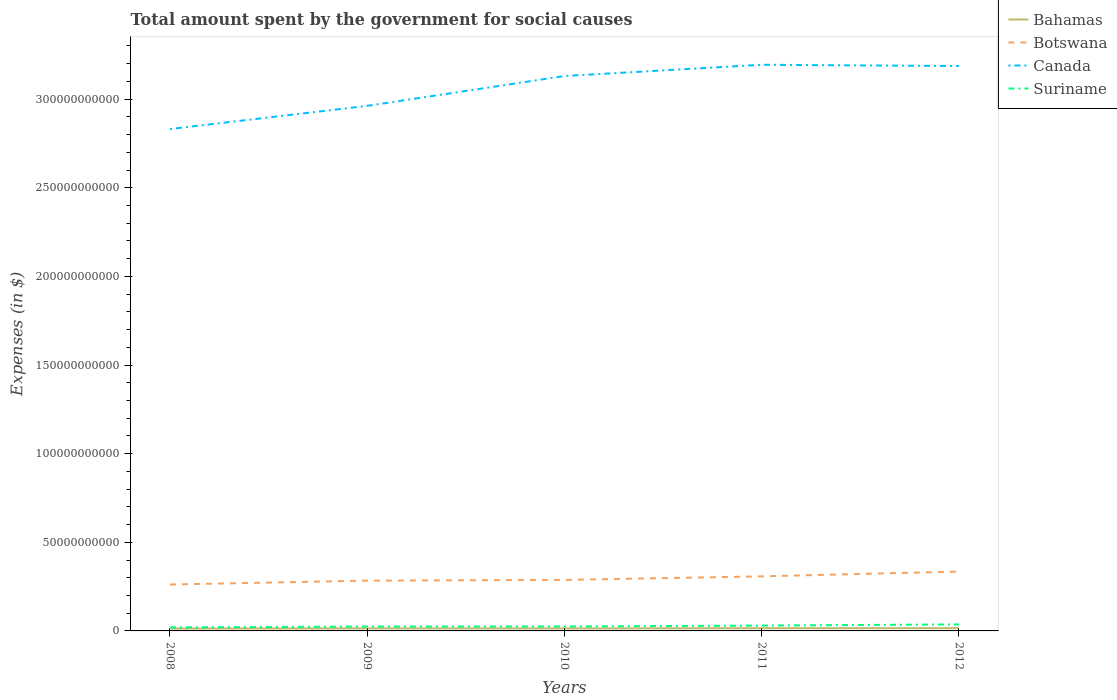Does the line corresponding to Botswana intersect with the line corresponding to Suriname?
Your answer should be compact. No. Is the number of lines equal to the number of legend labels?
Offer a very short reply. Yes. Across all years, what is the maximum amount spent for social causes by the government in Bahamas?
Make the answer very short. 1.34e+09. In which year was the amount spent for social causes by the government in Botswana maximum?
Offer a very short reply. 2008. What is the total amount spent for social causes by the government in Canada in the graph?
Give a very brief answer. -5.62e+09. What is the difference between the highest and the second highest amount spent for social causes by the government in Canada?
Provide a succinct answer. 3.63e+1. Is the amount spent for social causes by the government in Bahamas strictly greater than the amount spent for social causes by the government in Suriname over the years?
Provide a short and direct response. Yes. Are the values on the major ticks of Y-axis written in scientific E-notation?
Provide a short and direct response. No. Does the graph contain grids?
Give a very brief answer. No. How many legend labels are there?
Offer a terse response. 4. How are the legend labels stacked?
Offer a very short reply. Vertical. What is the title of the graph?
Offer a very short reply. Total amount spent by the government for social causes. Does "Trinidad and Tobago" appear as one of the legend labels in the graph?
Give a very brief answer. No. What is the label or title of the X-axis?
Give a very brief answer. Years. What is the label or title of the Y-axis?
Your answer should be very brief. Expenses (in $). What is the Expenses (in $) of Bahamas in 2008?
Make the answer very short. 1.34e+09. What is the Expenses (in $) in Botswana in 2008?
Offer a terse response. 2.62e+1. What is the Expenses (in $) in Canada in 2008?
Provide a short and direct response. 2.83e+11. What is the Expenses (in $) in Suriname in 2008?
Make the answer very short. 1.99e+09. What is the Expenses (in $) of Bahamas in 2009?
Keep it short and to the point. 1.42e+09. What is the Expenses (in $) of Botswana in 2009?
Provide a succinct answer. 2.84e+1. What is the Expenses (in $) in Canada in 2009?
Your answer should be very brief. 2.96e+11. What is the Expenses (in $) in Suriname in 2009?
Offer a very short reply. 2.47e+09. What is the Expenses (in $) in Bahamas in 2010?
Offer a terse response. 1.40e+09. What is the Expenses (in $) in Botswana in 2010?
Give a very brief answer. 2.88e+1. What is the Expenses (in $) of Canada in 2010?
Keep it short and to the point. 3.13e+11. What is the Expenses (in $) of Suriname in 2010?
Ensure brevity in your answer.  2.50e+09. What is the Expenses (in $) of Bahamas in 2011?
Your response must be concise. 1.53e+09. What is the Expenses (in $) in Botswana in 2011?
Offer a terse response. 3.08e+1. What is the Expenses (in $) of Canada in 2011?
Provide a short and direct response. 3.19e+11. What is the Expenses (in $) of Suriname in 2011?
Offer a very short reply. 3.02e+09. What is the Expenses (in $) in Bahamas in 2012?
Offer a very short reply. 1.55e+09. What is the Expenses (in $) of Botswana in 2012?
Provide a succinct answer. 3.35e+1. What is the Expenses (in $) of Canada in 2012?
Your response must be concise. 3.19e+11. What is the Expenses (in $) of Suriname in 2012?
Offer a very short reply. 3.68e+09. Across all years, what is the maximum Expenses (in $) of Bahamas?
Ensure brevity in your answer.  1.55e+09. Across all years, what is the maximum Expenses (in $) of Botswana?
Your answer should be compact. 3.35e+1. Across all years, what is the maximum Expenses (in $) of Canada?
Your response must be concise. 3.19e+11. Across all years, what is the maximum Expenses (in $) of Suriname?
Offer a terse response. 3.68e+09. Across all years, what is the minimum Expenses (in $) in Bahamas?
Offer a terse response. 1.34e+09. Across all years, what is the minimum Expenses (in $) of Botswana?
Provide a short and direct response. 2.62e+1. Across all years, what is the minimum Expenses (in $) of Canada?
Ensure brevity in your answer.  2.83e+11. Across all years, what is the minimum Expenses (in $) of Suriname?
Your answer should be very brief. 1.99e+09. What is the total Expenses (in $) in Bahamas in the graph?
Offer a terse response. 7.24e+09. What is the total Expenses (in $) in Botswana in the graph?
Your answer should be very brief. 1.48e+11. What is the total Expenses (in $) in Canada in the graph?
Give a very brief answer. 1.53e+12. What is the total Expenses (in $) of Suriname in the graph?
Give a very brief answer. 1.37e+1. What is the difference between the Expenses (in $) of Bahamas in 2008 and that in 2009?
Keep it short and to the point. -7.68e+07. What is the difference between the Expenses (in $) of Botswana in 2008 and that in 2009?
Offer a very short reply. -2.17e+09. What is the difference between the Expenses (in $) in Canada in 2008 and that in 2009?
Provide a succinct answer. -1.31e+1. What is the difference between the Expenses (in $) of Suriname in 2008 and that in 2009?
Keep it short and to the point. -4.80e+08. What is the difference between the Expenses (in $) of Bahamas in 2008 and that in 2010?
Make the answer very short. -5.18e+07. What is the difference between the Expenses (in $) of Botswana in 2008 and that in 2010?
Make the answer very short. -2.58e+09. What is the difference between the Expenses (in $) in Canada in 2008 and that in 2010?
Ensure brevity in your answer.  -2.99e+1. What is the difference between the Expenses (in $) in Suriname in 2008 and that in 2010?
Your answer should be very brief. -5.14e+08. What is the difference between the Expenses (in $) in Bahamas in 2008 and that in 2011?
Your answer should be very brief. -1.82e+08. What is the difference between the Expenses (in $) of Botswana in 2008 and that in 2011?
Make the answer very short. -4.59e+09. What is the difference between the Expenses (in $) of Canada in 2008 and that in 2011?
Provide a short and direct response. -3.63e+1. What is the difference between the Expenses (in $) of Suriname in 2008 and that in 2011?
Give a very brief answer. -1.03e+09. What is the difference between the Expenses (in $) in Bahamas in 2008 and that in 2012?
Offer a terse response. -2.08e+08. What is the difference between the Expenses (in $) in Botswana in 2008 and that in 2012?
Keep it short and to the point. -7.30e+09. What is the difference between the Expenses (in $) of Canada in 2008 and that in 2012?
Keep it short and to the point. -3.55e+1. What is the difference between the Expenses (in $) of Suriname in 2008 and that in 2012?
Offer a very short reply. -1.69e+09. What is the difference between the Expenses (in $) in Bahamas in 2009 and that in 2010?
Your answer should be very brief. 2.50e+07. What is the difference between the Expenses (in $) of Botswana in 2009 and that in 2010?
Ensure brevity in your answer.  -4.12e+08. What is the difference between the Expenses (in $) in Canada in 2009 and that in 2010?
Ensure brevity in your answer.  -1.68e+1. What is the difference between the Expenses (in $) of Suriname in 2009 and that in 2010?
Ensure brevity in your answer.  -3.39e+07. What is the difference between the Expenses (in $) in Bahamas in 2009 and that in 2011?
Your answer should be compact. -1.06e+08. What is the difference between the Expenses (in $) in Botswana in 2009 and that in 2011?
Give a very brief answer. -2.42e+09. What is the difference between the Expenses (in $) in Canada in 2009 and that in 2011?
Give a very brief answer. -2.32e+1. What is the difference between the Expenses (in $) in Suriname in 2009 and that in 2011?
Ensure brevity in your answer.  -5.52e+08. What is the difference between the Expenses (in $) in Bahamas in 2009 and that in 2012?
Offer a terse response. -1.32e+08. What is the difference between the Expenses (in $) in Botswana in 2009 and that in 2012?
Offer a very short reply. -5.13e+09. What is the difference between the Expenses (in $) of Canada in 2009 and that in 2012?
Keep it short and to the point. -2.25e+1. What is the difference between the Expenses (in $) in Suriname in 2009 and that in 2012?
Ensure brevity in your answer.  -1.21e+09. What is the difference between the Expenses (in $) in Bahamas in 2010 and that in 2011?
Provide a short and direct response. -1.31e+08. What is the difference between the Expenses (in $) of Botswana in 2010 and that in 2011?
Give a very brief answer. -2.00e+09. What is the difference between the Expenses (in $) in Canada in 2010 and that in 2011?
Make the answer very short. -6.35e+09. What is the difference between the Expenses (in $) of Suriname in 2010 and that in 2011?
Ensure brevity in your answer.  -5.18e+08. What is the difference between the Expenses (in $) in Bahamas in 2010 and that in 2012?
Ensure brevity in your answer.  -1.57e+08. What is the difference between the Expenses (in $) in Botswana in 2010 and that in 2012?
Your answer should be very brief. -4.72e+09. What is the difference between the Expenses (in $) in Canada in 2010 and that in 2012?
Your answer should be compact. -5.62e+09. What is the difference between the Expenses (in $) in Suriname in 2010 and that in 2012?
Provide a succinct answer. -1.18e+09. What is the difference between the Expenses (in $) of Bahamas in 2011 and that in 2012?
Your answer should be compact. -2.60e+07. What is the difference between the Expenses (in $) in Botswana in 2011 and that in 2012?
Provide a short and direct response. -2.71e+09. What is the difference between the Expenses (in $) of Canada in 2011 and that in 2012?
Make the answer very short. 7.23e+08. What is the difference between the Expenses (in $) in Suriname in 2011 and that in 2012?
Offer a very short reply. -6.62e+08. What is the difference between the Expenses (in $) of Bahamas in 2008 and the Expenses (in $) of Botswana in 2009?
Ensure brevity in your answer.  -2.70e+1. What is the difference between the Expenses (in $) in Bahamas in 2008 and the Expenses (in $) in Canada in 2009?
Offer a terse response. -2.95e+11. What is the difference between the Expenses (in $) of Bahamas in 2008 and the Expenses (in $) of Suriname in 2009?
Your response must be concise. -1.12e+09. What is the difference between the Expenses (in $) of Botswana in 2008 and the Expenses (in $) of Canada in 2009?
Ensure brevity in your answer.  -2.70e+11. What is the difference between the Expenses (in $) of Botswana in 2008 and the Expenses (in $) of Suriname in 2009?
Your answer should be compact. 2.37e+1. What is the difference between the Expenses (in $) of Canada in 2008 and the Expenses (in $) of Suriname in 2009?
Ensure brevity in your answer.  2.81e+11. What is the difference between the Expenses (in $) in Bahamas in 2008 and the Expenses (in $) in Botswana in 2010?
Your answer should be very brief. -2.74e+1. What is the difference between the Expenses (in $) in Bahamas in 2008 and the Expenses (in $) in Canada in 2010?
Make the answer very short. -3.12e+11. What is the difference between the Expenses (in $) in Bahamas in 2008 and the Expenses (in $) in Suriname in 2010?
Keep it short and to the point. -1.16e+09. What is the difference between the Expenses (in $) in Botswana in 2008 and the Expenses (in $) in Canada in 2010?
Make the answer very short. -2.87e+11. What is the difference between the Expenses (in $) of Botswana in 2008 and the Expenses (in $) of Suriname in 2010?
Offer a very short reply. 2.37e+1. What is the difference between the Expenses (in $) in Canada in 2008 and the Expenses (in $) in Suriname in 2010?
Make the answer very short. 2.81e+11. What is the difference between the Expenses (in $) of Bahamas in 2008 and the Expenses (in $) of Botswana in 2011?
Offer a terse response. -2.94e+1. What is the difference between the Expenses (in $) of Bahamas in 2008 and the Expenses (in $) of Canada in 2011?
Keep it short and to the point. -3.18e+11. What is the difference between the Expenses (in $) of Bahamas in 2008 and the Expenses (in $) of Suriname in 2011?
Give a very brief answer. -1.67e+09. What is the difference between the Expenses (in $) in Botswana in 2008 and the Expenses (in $) in Canada in 2011?
Provide a succinct answer. -2.93e+11. What is the difference between the Expenses (in $) in Botswana in 2008 and the Expenses (in $) in Suriname in 2011?
Ensure brevity in your answer.  2.32e+1. What is the difference between the Expenses (in $) in Canada in 2008 and the Expenses (in $) in Suriname in 2011?
Your answer should be compact. 2.80e+11. What is the difference between the Expenses (in $) of Bahamas in 2008 and the Expenses (in $) of Botswana in 2012?
Provide a short and direct response. -3.21e+1. What is the difference between the Expenses (in $) in Bahamas in 2008 and the Expenses (in $) in Canada in 2012?
Your response must be concise. -3.17e+11. What is the difference between the Expenses (in $) in Bahamas in 2008 and the Expenses (in $) in Suriname in 2012?
Make the answer very short. -2.34e+09. What is the difference between the Expenses (in $) in Botswana in 2008 and the Expenses (in $) in Canada in 2012?
Your response must be concise. -2.92e+11. What is the difference between the Expenses (in $) in Botswana in 2008 and the Expenses (in $) in Suriname in 2012?
Give a very brief answer. 2.25e+1. What is the difference between the Expenses (in $) in Canada in 2008 and the Expenses (in $) in Suriname in 2012?
Give a very brief answer. 2.79e+11. What is the difference between the Expenses (in $) of Bahamas in 2009 and the Expenses (in $) of Botswana in 2010?
Offer a terse response. -2.74e+1. What is the difference between the Expenses (in $) in Bahamas in 2009 and the Expenses (in $) in Canada in 2010?
Your answer should be compact. -3.12e+11. What is the difference between the Expenses (in $) in Bahamas in 2009 and the Expenses (in $) in Suriname in 2010?
Keep it short and to the point. -1.08e+09. What is the difference between the Expenses (in $) in Botswana in 2009 and the Expenses (in $) in Canada in 2010?
Keep it short and to the point. -2.85e+11. What is the difference between the Expenses (in $) in Botswana in 2009 and the Expenses (in $) in Suriname in 2010?
Ensure brevity in your answer.  2.59e+1. What is the difference between the Expenses (in $) in Canada in 2009 and the Expenses (in $) in Suriname in 2010?
Your response must be concise. 2.94e+11. What is the difference between the Expenses (in $) of Bahamas in 2009 and the Expenses (in $) of Botswana in 2011?
Provide a succinct answer. -2.94e+1. What is the difference between the Expenses (in $) of Bahamas in 2009 and the Expenses (in $) of Canada in 2011?
Your answer should be very brief. -3.18e+11. What is the difference between the Expenses (in $) of Bahamas in 2009 and the Expenses (in $) of Suriname in 2011?
Offer a terse response. -1.60e+09. What is the difference between the Expenses (in $) in Botswana in 2009 and the Expenses (in $) in Canada in 2011?
Provide a succinct answer. -2.91e+11. What is the difference between the Expenses (in $) in Botswana in 2009 and the Expenses (in $) in Suriname in 2011?
Offer a terse response. 2.53e+1. What is the difference between the Expenses (in $) in Canada in 2009 and the Expenses (in $) in Suriname in 2011?
Your response must be concise. 2.93e+11. What is the difference between the Expenses (in $) in Bahamas in 2009 and the Expenses (in $) in Botswana in 2012?
Provide a succinct answer. -3.21e+1. What is the difference between the Expenses (in $) of Bahamas in 2009 and the Expenses (in $) of Canada in 2012?
Your response must be concise. -3.17e+11. What is the difference between the Expenses (in $) of Bahamas in 2009 and the Expenses (in $) of Suriname in 2012?
Your answer should be very brief. -2.26e+09. What is the difference between the Expenses (in $) in Botswana in 2009 and the Expenses (in $) in Canada in 2012?
Keep it short and to the point. -2.90e+11. What is the difference between the Expenses (in $) in Botswana in 2009 and the Expenses (in $) in Suriname in 2012?
Offer a very short reply. 2.47e+1. What is the difference between the Expenses (in $) of Canada in 2009 and the Expenses (in $) of Suriname in 2012?
Provide a short and direct response. 2.93e+11. What is the difference between the Expenses (in $) of Bahamas in 2010 and the Expenses (in $) of Botswana in 2011?
Offer a very short reply. -2.94e+1. What is the difference between the Expenses (in $) of Bahamas in 2010 and the Expenses (in $) of Canada in 2011?
Offer a very short reply. -3.18e+11. What is the difference between the Expenses (in $) of Bahamas in 2010 and the Expenses (in $) of Suriname in 2011?
Keep it short and to the point. -1.62e+09. What is the difference between the Expenses (in $) in Botswana in 2010 and the Expenses (in $) in Canada in 2011?
Provide a short and direct response. -2.91e+11. What is the difference between the Expenses (in $) of Botswana in 2010 and the Expenses (in $) of Suriname in 2011?
Make the answer very short. 2.58e+1. What is the difference between the Expenses (in $) in Canada in 2010 and the Expenses (in $) in Suriname in 2011?
Offer a terse response. 3.10e+11. What is the difference between the Expenses (in $) of Bahamas in 2010 and the Expenses (in $) of Botswana in 2012?
Your answer should be very brief. -3.21e+1. What is the difference between the Expenses (in $) in Bahamas in 2010 and the Expenses (in $) in Canada in 2012?
Offer a terse response. -3.17e+11. What is the difference between the Expenses (in $) of Bahamas in 2010 and the Expenses (in $) of Suriname in 2012?
Your answer should be very brief. -2.28e+09. What is the difference between the Expenses (in $) of Botswana in 2010 and the Expenses (in $) of Canada in 2012?
Provide a short and direct response. -2.90e+11. What is the difference between the Expenses (in $) in Botswana in 2010 and the Expenses (in $) in Suriname in 2012?
Provide a short and direct response. 2.51e+1. What is the difference between the Expenses (in $) of Canada in 2010 and the Expenses (in $) of Suriname in 2012?
Offer a terse response. 3.09e+11. What is the difference between the Expenses (in $) in Bahamas in 2011 and the Expenses (in $) in Botswana in 2012?
Offer a terse response. -3.20e+1. What is the difference between the Expenses (in $) of Bahamas in 2011 and the Expenses (in $) of Canada in 2012?
Make the answer very short. -3.17e+11. What is the difference between the Expenses (in $) in Bahamas in 2011 and the Expenses (in $) in Suriname in 2012?
Your answer should be very brief. -2.15e+09. What is the difference between the Expenses (in $) of Botswana in 2011 and the Expenses (in $) of Canada in 2012?
Make the answer very short. -2.88e+11. What is the difference between the Expenses (in $) in Botswana in 2011 and the Expenses (in $) in Suriname in 2012?
Offer a terse response. 2.71e+1. What is the difference between the Expenses (in $) of Canada in 2011 and the Expenses (in $) of Suriname in 2012?
Offer a terse response. 3.16e+11. What is the average Expenses (in $) in Bahamas per year?
Provide a short and direct response. 1.45e+09. What is the average Expenses (in $) of Botswana per year?
Your answer should be compact. 2.95e+1. What is the average Expenses (in $) in Canada per year?
Offer a very short reply. 3.06e+11. What is the average Expenses (in $) of Suriname per year?
Your answer should be compact. 2.73e+09. In the year 2008, what is the difference between the Expenses (in $) of Bahamas and Expenses (in $) of Botswana?
Your answer should be compact. -2.48e+1. In the year 2008, what is the difference between the Expenses (in $) in Bahamas and Expenses (in $) in Canada?
Ensure brevity in your answer.  -2.82e+11. In the year 2008, what is the difference between the Expenses (in $) in Bahamas and Expenses (in $) in Suriname?
Make the answer very short. -6.42e+08. In the year 2008, what is the difference between the Expenses (in $) of Botswana and Expenses (in $) of Canada?
Your answer should be compact. -2.57e+11. In the year 2008, what is the difference between the Expenses (in $) of Botswana and Expenses (in $) of Suriname?
Give a very brief answer. 2.42e+1. In the year 2008, what is the difference between the Expenses (in $) of Canada and Expenses (in $) of Suriname?
Provide a succinct answer. 2.81e+11. In the year 2009, what is the difference between the Expenses (in $) of Bahamas and Expenses (in $) of Botswana?
Offer a terse response. -2.69e+1. In the year 2009, what is the difference between the Expenses (in $) in Bahamas and Expenses (in $) in Canada?
Ensure brevity in your answer.  -2.95e+11. In the year 2009, what is the difference between the Expenses (in $) of Bahamas and Expenses (in $) of Suriname?
Your response must be concise. -1.05e+09. In the year 2009, what is the difference between the Expenses (in $) in Botswana and Expenses (in $) in Canada?
Your answer should be very brief. -2.68e+11. In the year 2009, what is the difference between the Expenses (in $) in Botswana and Expenses (in $) in Suriname?
Ensure brevity in your answer.  2.59e+1. In the year 2009, what is the difference between the Expenses (in $) in Canada and Expenses (in $) in Suriname?
Your response must be concise. 2.94e+11. In the year 2010, what is the difference between the Expenses (in $) in Bahamas and Expenses (in $) in Botswana?
Provide a succinct answer. -2.74e+1. In the year 2010, what is the difference between the Expenses (in $) of Bahamas and Expenses (in $) of Canada?
Your answer should be compact. -3.12e+11. In the year 2010, what is the difference between the Expenses (in $) in Bahamas and Expenses (in $) in Suriname?
Provide a succinct answer. -1.10e+09. In the year 2010, what is the difference between the Expenses (in $) of Botswana and Expenses (in $) of Canada?
Your answer should be very brief. -2.84e+11. In the year 2010, what is the difference between the Expenses (in $) of Botswana and Expenses (in $) of Suriname?
Keep it short and to the point. 2.63e+1. In the year 2010, what is the difference between the Expenses (in $) in Canada and Expenses (in $) in Suriname?
Offer a very short reply. 3.11e+11. In the year 2011, what is the difference between the Expenses (in $) of Bahamas and Expenses (in $) of Botswana?
Provide a succinct answer. -2.93e+1. In the year 2011, what is the difference between the Expenses (in $) of Bahamas and Expenses (in $) of Canada?
Make the answer very short. -3.18e+11. In the year 2011, what is the difference between the Expenses (in $) in Bahamas and Expenses (in $) in Suriname?
Ensure brevity in your answer.  -1.49e+09. In the year 2011, what is the difference between the Expenses (in $) in Botswana and Expenses (in $) in Canada?
Your answer should be compact. -2.89e+11. In the year 2011, what is the difference between the Expenses (in $) in Botswana and Expenses (in $) in Suriname?
Make the answer very short. 2.78e+1. In the year 2011, what is the difference between the Expenses (in $) of Canada and Expenses (in $) of Suriname?
Your answer should be compact. 3.16e+11. In the year 2012, what is the difference between the Expenses (in $) of Bahamas and Expenses (in $) of Botswana?
Provide a short and direct response. -3.19e+1. In the year 2012, what is the difference between the Expenses (in $) of Bahamas and Expenses (in $) of Canada?
Keep it short and to the point. -3.17e+11. In the year 2012, what is the difference between the Expenses (in $) of Bahamas and Expenses (in $) of Suriname?
Give a very brief answer. -2.13e+09. In the year 2012, what is the difference between the Expenses (in $) of Botswana and Expenses (in $) of Canada?
Provide a succinct answer. -2.85e+11. In the year 2012, what is the difference between the Expenses (in $) of Botswana and Expenses (in $) of Suriname?
Ensure brevity in your answer.  2.98e+1. In the year 2012, what is the difference between the Expenses (in $) of Canada and Expenses (in $) of Suriname?
Your answer should be compact. 3.15e+11. What is the ratio of the Expenses (in $) in Bahamas in 2008 to that in 2009?
Make the answer very short. 0.95. What is the ratio of the Expenses (in $) of Botswana in 2008 to that in 2009?
Your response must be concise. 0.92. What is the ratio of the Expenses (in $) in Canada in 2008 to that in 2009?
Provide a short and direct response. 0.96. What is the ratio of the Expenses (in $) of Suriname in 2008 to that in 2009?
Make the answer very short. 0.81. What is the ratio of the Expenses (in $) of Bahamas in 2008 to that in 2010?
Offer a very short reply. 0.96. What is the ratio of the Expenses (in $) in Botswana in 2008 to that in 2010?
Your answer should be very brief. 0.91. What is the ratio of the Expenses (in $) of Canada in 2008 to that in 2010?
Offer a terse response. 0.9. What is the ratio of the Expenses (in $) of Suriname in 2008 to that in 2010?
Ensure brevity in your answer.  0.79. What is the ratio of the Expenses (in $) of Bahamas in 2008 to that in 2011?
Your answer should be compact. 0.88. What is the ratio of the Expenses (in $) of Botswana in 2008 to that in 2011?
Your response must be concise. 0.85. What is the ratio of the Expenses (in $) in Canada in 2008 to that in 2011?
Offer a terse response. 0.89. What is the ratio of the Expenses (in $) in Suriname in 2008 to that in 2011?
Your answer should be compact. 0.66. What is the ratio of the Expenses (in $) in Bahamas in 2008 to that in 2012?
Make the answer very short. 0.87. What is the ratio of the Expenses (in $) of Botswana in 2008 to that in 2012?
Give a very brief answer. 0.78. What is the ratio of the Expenses (in $) of Canada in 2008 to that in 2012?
Your answer should be compact. 0.89. What is the ratio of the Expenses (in $) in Suriname in 2008 to that in 2012?
Your answer should be compact. 0.54. What is the ratio of the Expenses (in $) in Bahamas in 2009 to that in 2010?
Your answer should be very brief. 1.02. What is the ratio of the Expenses (in $) of Botswana in 2009 to that in 2010?
Keep it short and to the point. 0.99. What is the ratio of the Expenses (in $) of Canada in 2009 to that in 2010?
Provide a succinct answer. 0.95. What is the ratio of the Expenses (in $) in Suriname in 2009 to that in 2010?
Provide a succinct answer. 0.99. What is the ratio of the Expenses (in $) in Bahamas in 2009 to that in 2011?
Provide a succinct answer. 0.93. What is the ratio of the Expenses (in $) in Botswana in 2009 to that in 2011?
Your response must be concise. 0.92. What is the ratio of the Expenses (in $) of Canada in 2009 to that in 2011?
Provide a succinct answer. 0.93. What is the ratio of the Expenses (in $) of Suriname in 2009 to that in 2011?
Make the answer very short. 0.82. What is the ratio of the Expenses (in $) in Bahamas in 2009 to that in 2012?
Offer a very short reply. 0.92. What is the ratio of the Expenses (in $) in Botswana in 2009 to that in 2012?
Give a very brief answer. 0.85. What is the ratio of the Expenses (in $) in Canada in 2009 to that in 2012?
Provide a short and direct response. 0.93. What is the ratio of the Expenses (in $) of Suriname in 2009 to that in 2012?
Your answer should be very brief. 0.67. What is the ratio of the Expenses (in $) of Bahamas in 2010 to that in 2011?
Provide a short and direct response. 0.91. What is the ratio of the Expenses (in $) in Botswana in 2010 to that in 2011?
Give a very brief answer. 0.93. What is the ratio of the Expenses (in $) in Canada in 2010 to that in 2011?
Offer a very short reply. 0.98. What is the ratio of the Expenses (in $) of Suriname in 2010 to that in 2011?
Give a very brief answer. 0.83. What is the ratio of the Expenses (in $) in Bahamas in 2010 to that in 2012?
Ensure brevity in your answer.  0.9. What is the ratio of the Expenses (in $) in Botswana in 2010 to that in 2012?
Your answer should be very brief. 0.86. What is the ratio of the Expenses (in $) in Canada in 2010 to that in 2012?
Offer a very short reply. 0.98. What is the ratio of the Expenses (in $) in Suriname in 2010 to that in 2012?
Offer a terse response. 0.68. What is the ratio of the Expenses (in $) in Bahamas in 2011 to that in 2012?
Your response must be concise. 0.98. What is the ratio of the Expenses (in $) of Botswana in 2011 to that in 2012?
Make the answer very short. 0.92. What is the ratio of the Expenses (in $) of Suriname in 2011 to that in 2012?
Your answer should be compact. 0.82. What is the difference between the highest and the second highest Expenses (in $) of Bahamas?
Your answer should be compact. 2.60e+07. What is the difference between the highest and the second highest Expenses (in $) of Botswana?
Your response must be concise. 2.71e+09. What is the difference between the highest and the second highest Expenses (in $) of Canada?
Provide a succinct answer. 7.23e+08. What is the difference between the highest and the second highest Expenses (in $) of Suriname?
Keep it short and to the point. 6.62e+08. What is the difference between the highest and the lowest Expenses (in $) in Bahamas?
Give a very brief answer. 2.08e+08. What is the difference between the highest and the lowest Expenses (in $) in Botswana?
Your answer should be very brief. 7.30e+09. What is the difference between the highest and the lowest Expenses (in $) of Canada?
Make the answer very short. 3.63e+1. What is the difference between the highest and the lowest Expenses (in $) of Suriname?
Make the answer very short. 1.69e+09. 